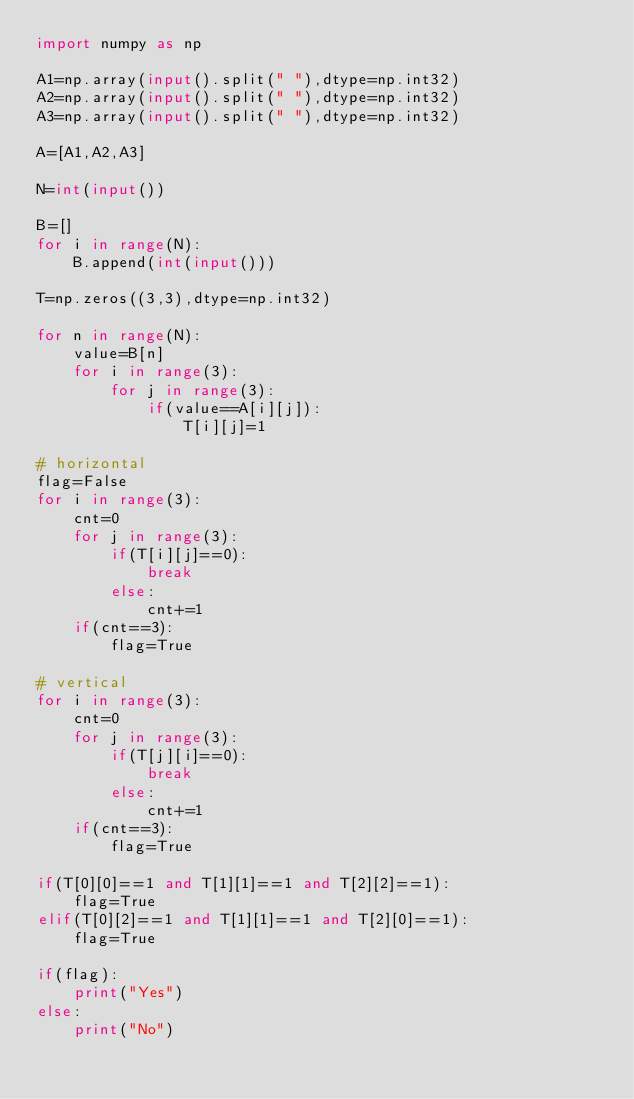Convert code to text. <code><loc_0><loc_0><loc_500><loc_500><_Python_>import numpy as np

A1=np.array(input().split(" "),dtype=np.int32)
A2=np.array(input().split(" "),dtype=np.int32)
A3=np.array(input().split(" "),dtype=np.int32)

A=[A1,A2,A3]

N=int(input())

B=[]
for i in range(N):
    B.append(int(input()))

T=np.zeros((3,3),dtype=np.int32)

for n in range(N):
    value=B[n]
    for i in range(3):
        for j in range(3):
            if(value==A[i][j]):
                T[i][j]=1

# horizontal
flag=False
for i in range(3):
    cnt=0
    for j in range(3):
        if(T[i][j]==0):
            break
        else:
            cnt+=1
    if(cnt==3):
        flag=True

# vertical
for i in range(3):
    cnt=0
    for j in range(3):
        if(T[j][i]==0):
            break
        else:
            cnt+=1
    if(cnt==3):
        flag=True

if(T[0][0]==1 and T[1][1]==1 and T[2][2]==1):
    flag=True
elif(T[0][2]==1 and T[1][1]==1 and T[2][0]==1):
    flag=True

if(flag):
    print("Yes")
else:
    print("No")</code> 